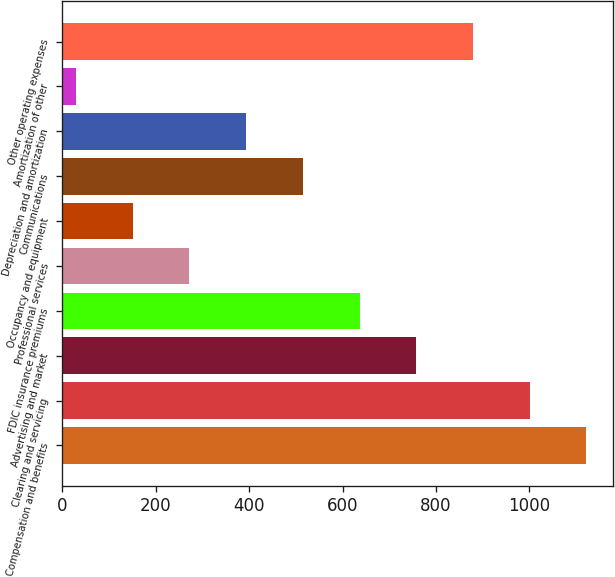Convert chart to OTSL. <chart><loc_0><loc_0><loc_500><loc_500><bar_chart><fcel>Compensation and benefits<fcel>Clearing and servicing<fcel>Advertising and market<fcel>FDIC insurance premiums<fcel>Professional services<fcel>Occupancy and equipment<fcel>Communications<fcel>Depreciation and amortization<fcel>Amortization of other<fcel>Other operating expenses<nl><fcel>1121.94<fcel>1000.58<fcel>757.86<fcel>636.5<fcel>272.42<fcel>151.06<fcel>515.14<fcel>393.78<fcel>29.7<fcel>879.22<nl></chart> 